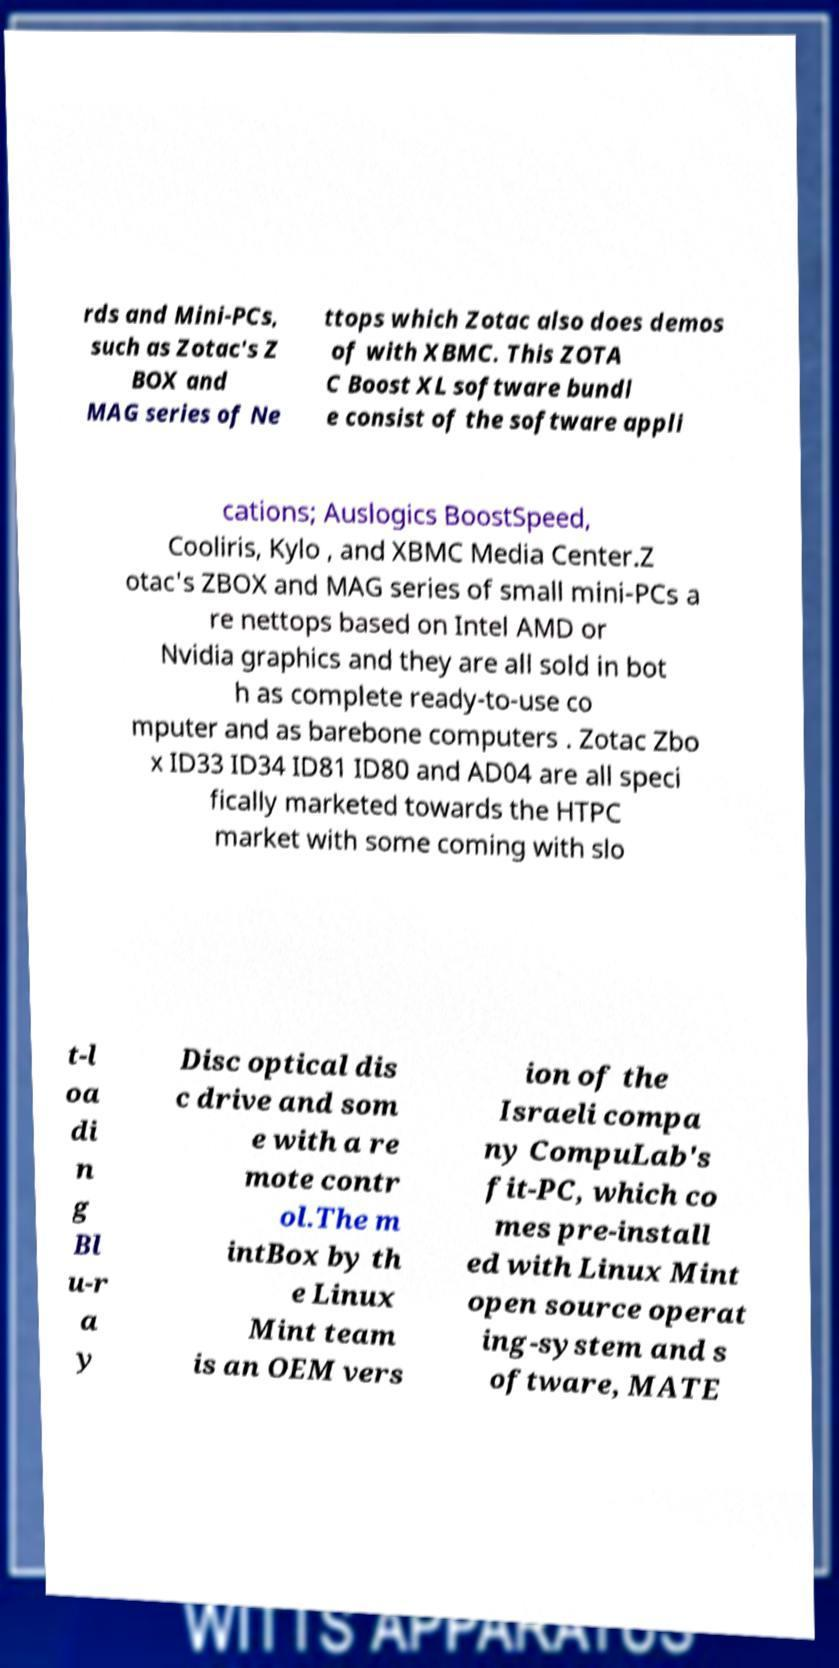For documentation purposes, I need the text within this image transcribed. Could you provide that? rds and Mini-PCs, such as Zotac's Z BOX and MAG series of Ne ttops which Zotac also does demos of with XBMC. This ZOTA C Boost XL software bundl e consist of the software appli cations; Auslogics BoostSpeed, Cooliris, Kylo , and XBMC Media Center.Z otac's ZBOX and MAG series of small mini-PCs a re nettops based on Intel AMD or Nvidia graphics and they are all sold in bot h as complete ready-to-use co mputer and as barebone computers . Zotac Zbo x ID33 ID34 ID81 ID80 and AD04 are all speci fically marketed towards the HTPC market with some coming with slo t-l oa di n g Bl u-r a y Disc optical dis c drive and som e with a re mote contr ol.The m intBox by th e Linux Mint team is an OEM vers ion of the Israeli compa ny CompuLab's fit-PC, which co mes pre-install ed with Linux Mint open source operat ing-system and s oftware, MATE 